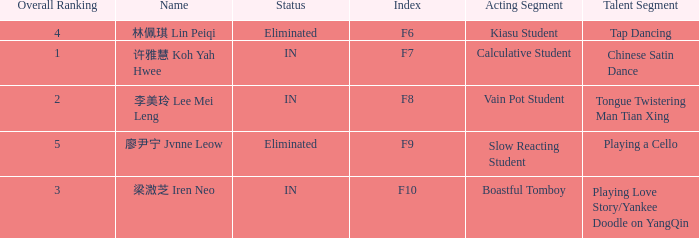What's the acting segment of 林佩琪 lin peiqi's events that are eliminated? Kiasu Student. 